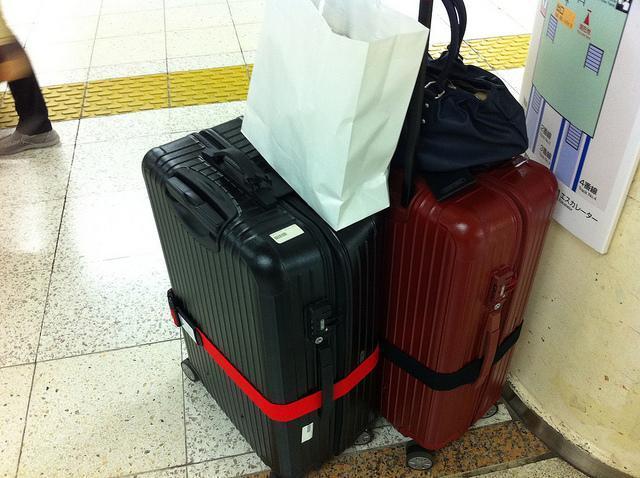How many red bags are in the picture?
Give a very brief answer. 1. How many suitcases are in the photo?
Give a very brief answer. 2. How many handbags are in the picture?
Give a very brief answer. 2. 